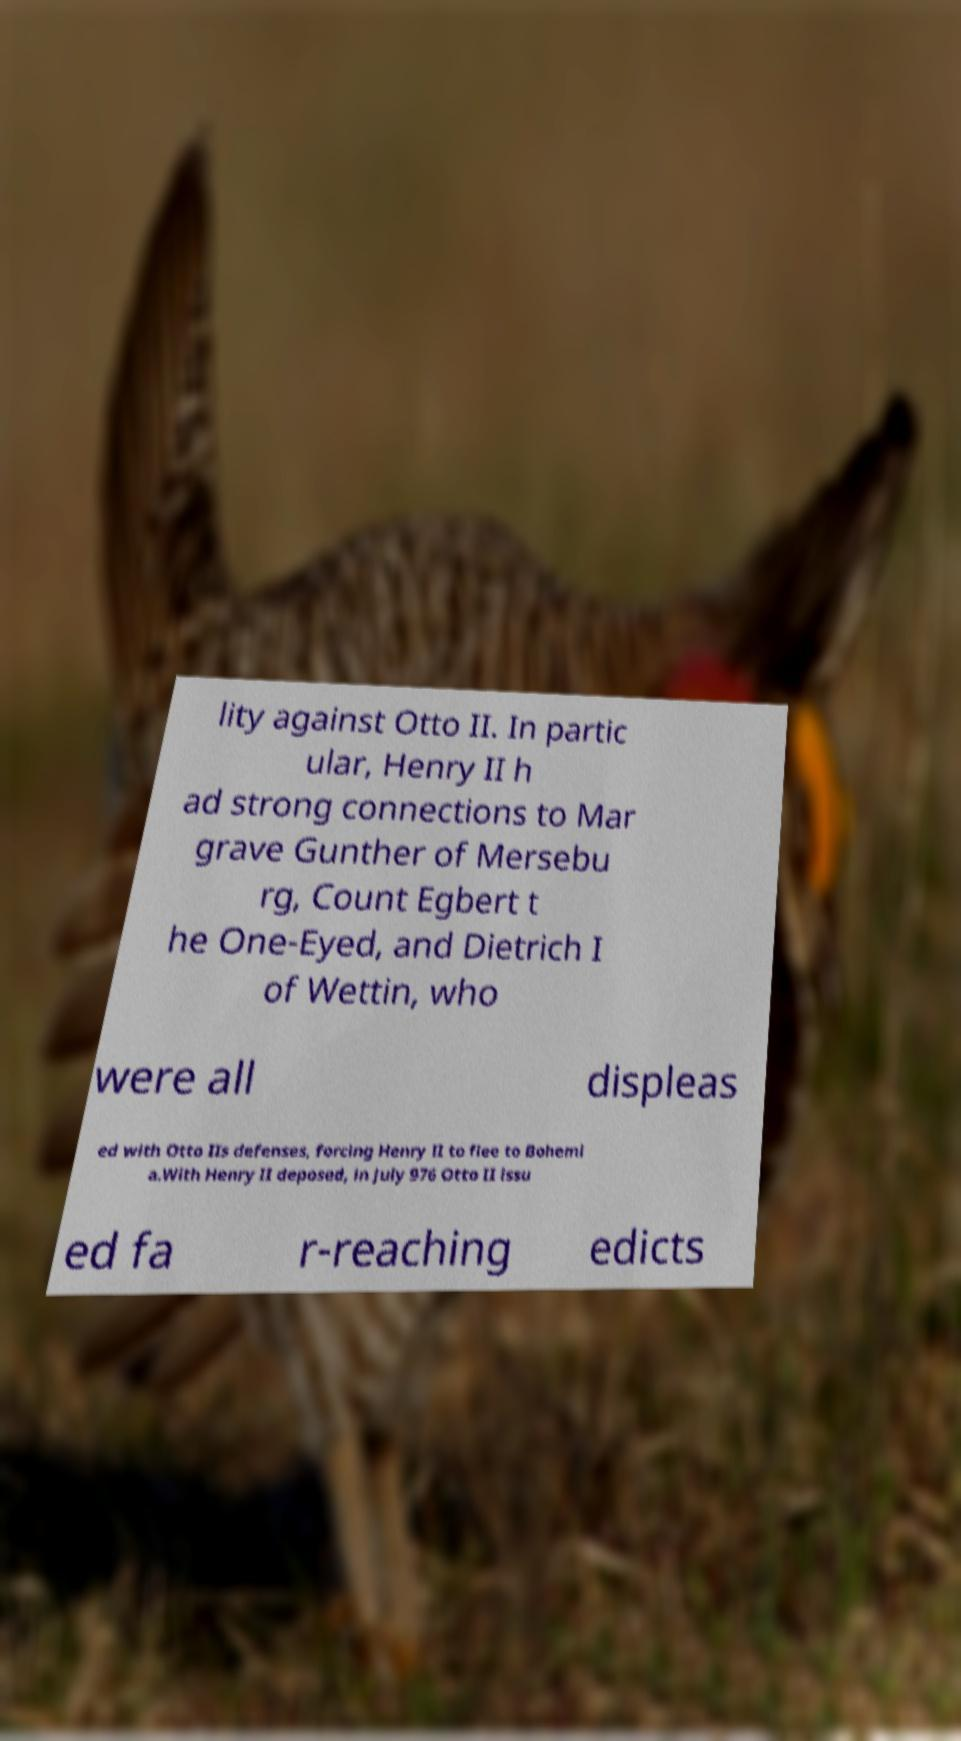Can you accurately transcribe the text from the provided image for me? lity against Otto II. In partic ular, Henry II h ad strong connections to Mar grave Gunther of Mersebu rg, Count Egbert t he One-Eyed, and Dietrich I of Wettin, who were all displeas ed with Otto IIs defenses, forcing Henry II to flee to Bohemi a.With Henry II deposed, in July 976 Otto II issu ed fa r-reaching edicts 